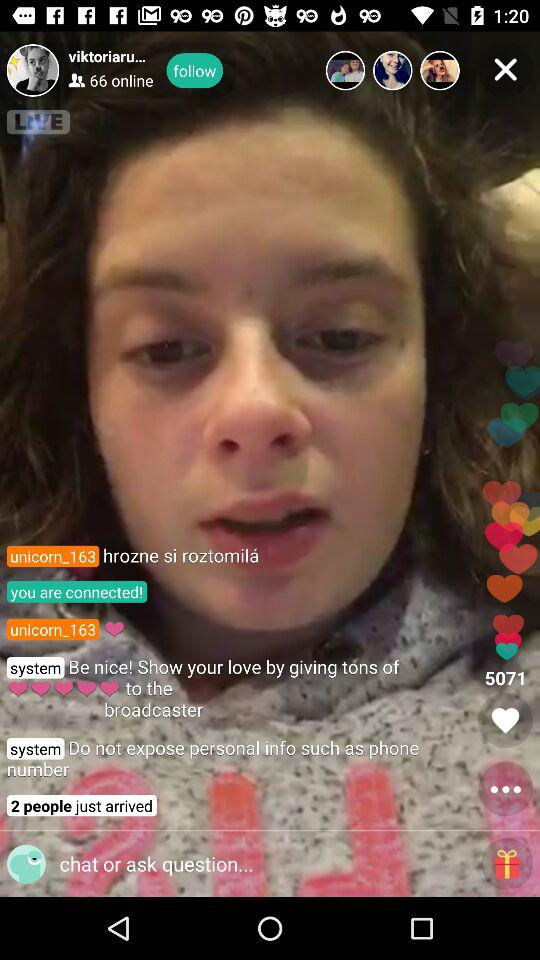How many likes are there? There are 5071 likes. 